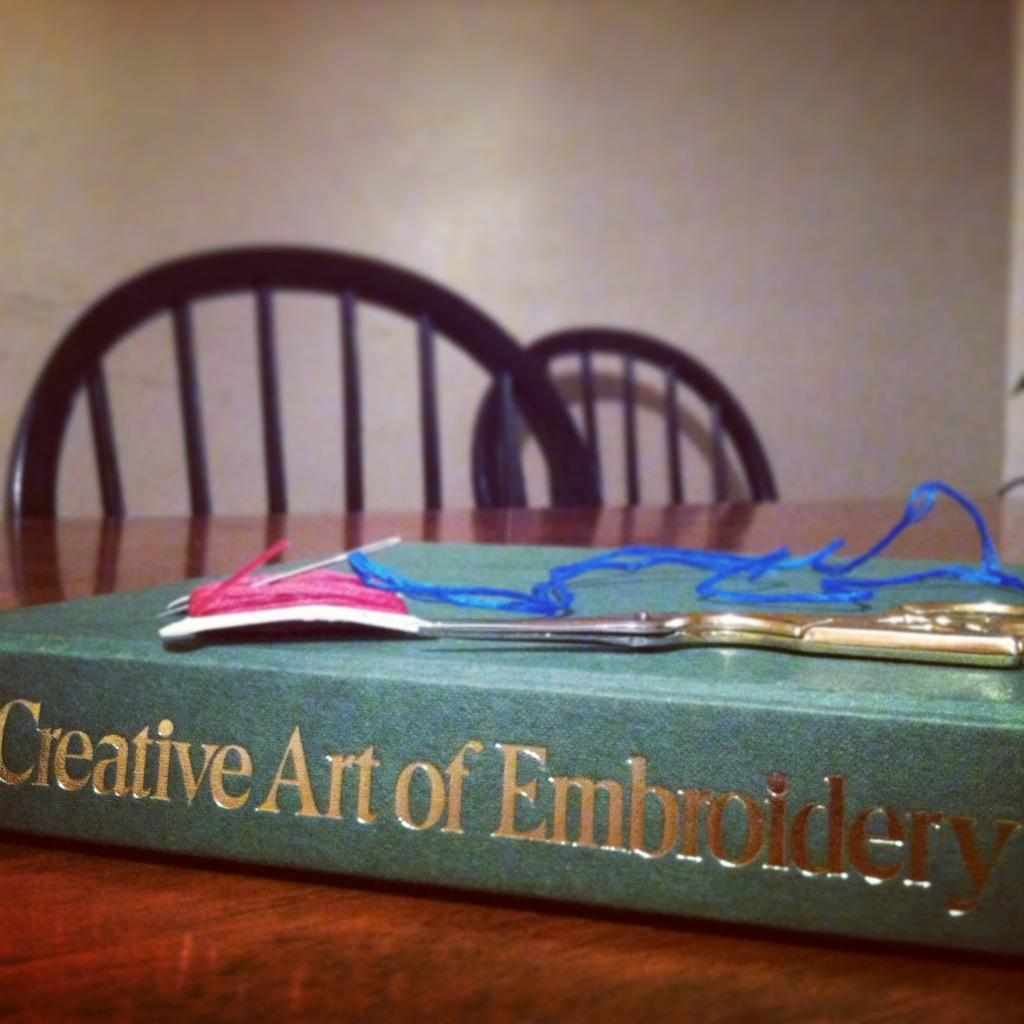<image>
Describe the image concisely. A book called Creative Art of Embroidery sits on a table. 